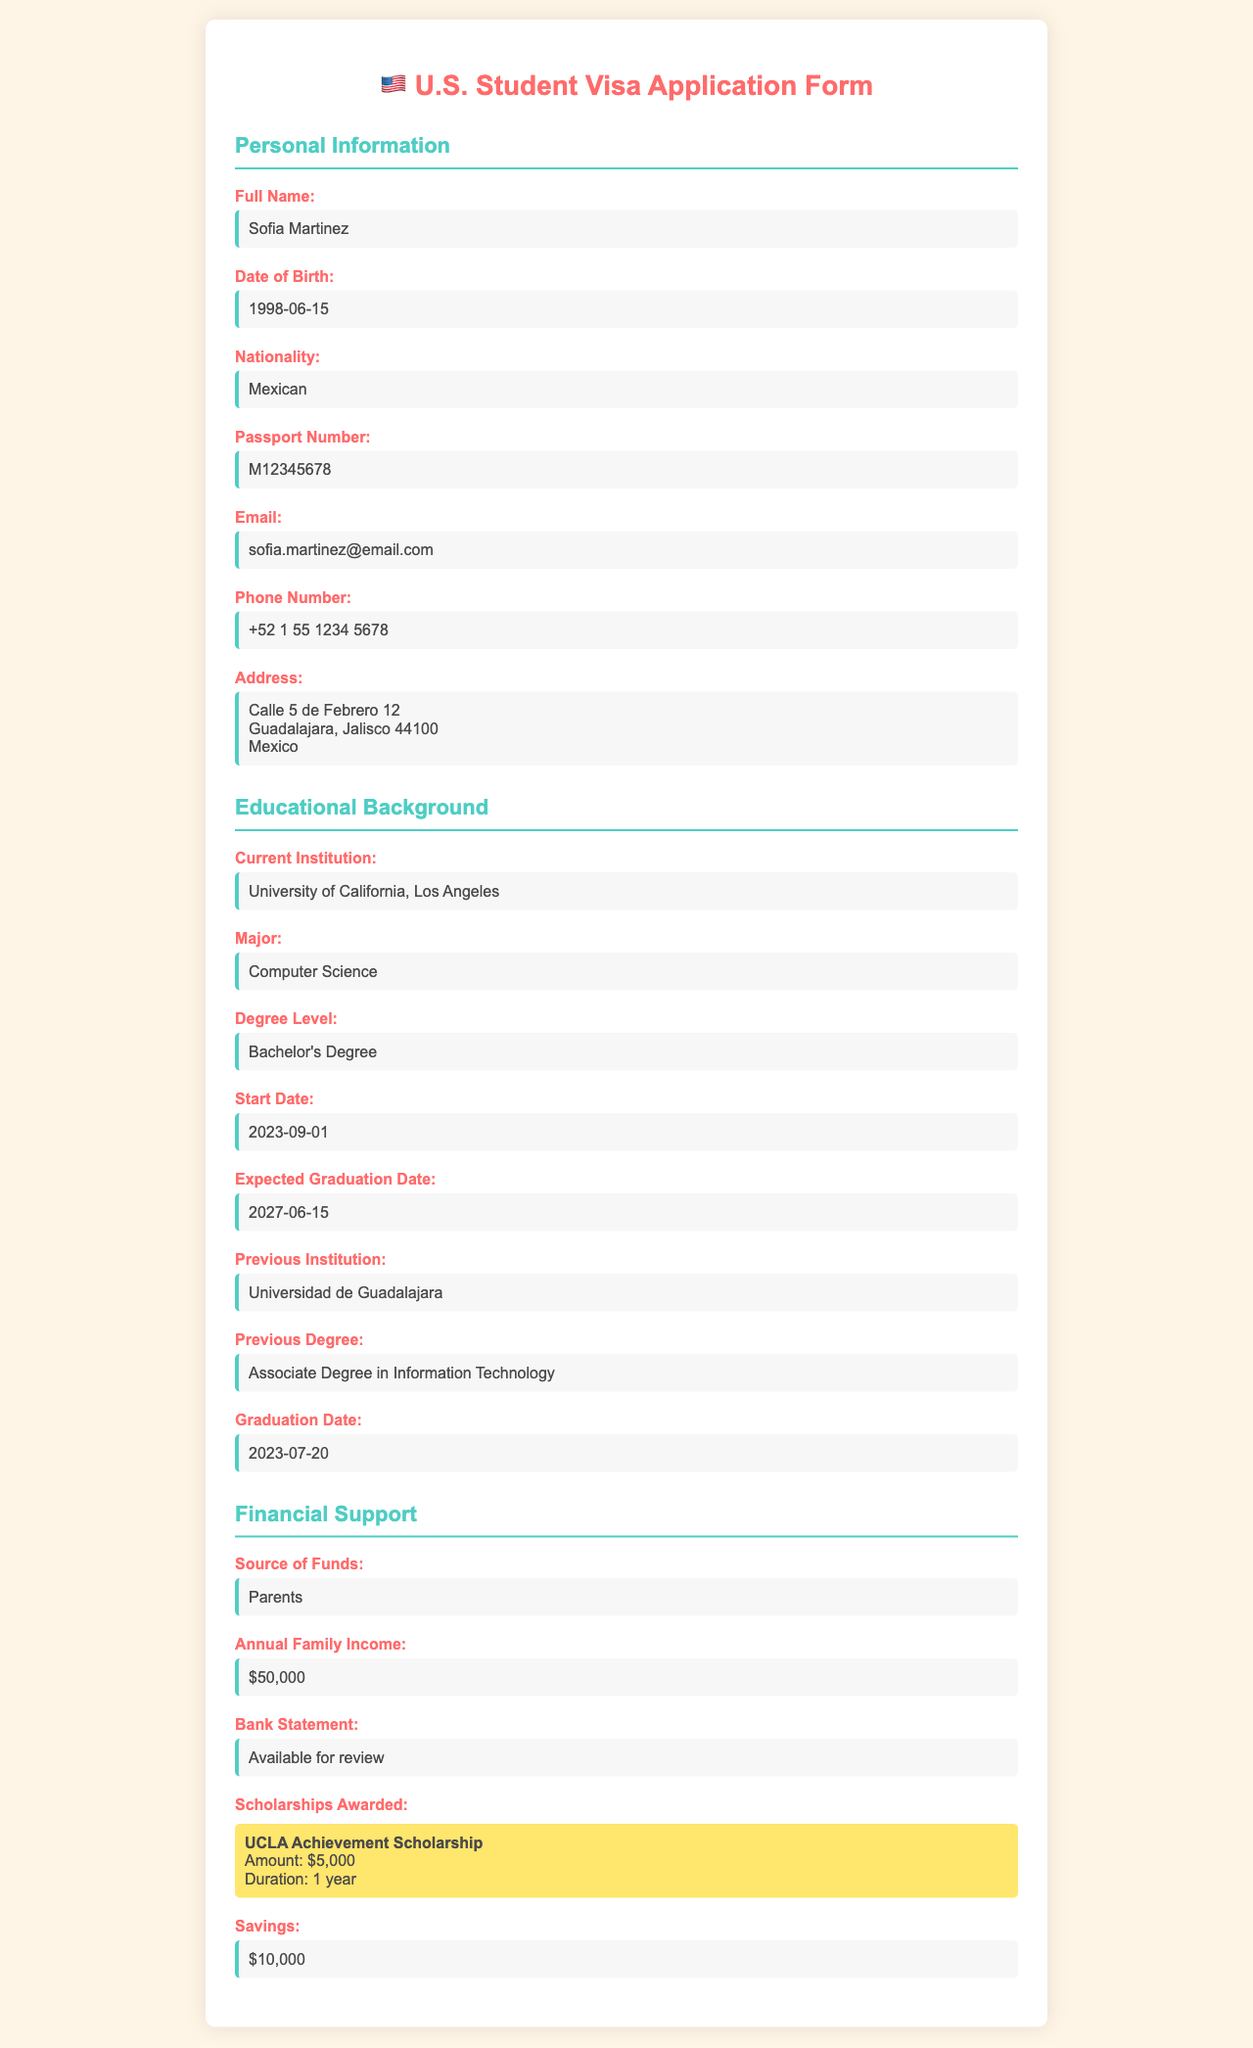What is the full name of the applicant? The applicant's full name is located in the Personal Information section.
Answer: Sofia Martinez What is the date of birth of the applicant? The date of birth can be found in the Personal Information section.
Answer: 1998-06-15 What is the major of the applicant's current institution? The applicant's major is indicated in the Educational Background section.
Answer: Computer Science What is the graduation date expected for the applicant? The expected graduation date is specified in the Educational Background section.
Answer: 2027-06-15 Who is the source of funds for the applicant's financial support? The source of funds is listed in the Financial Support section.
Answer: Parents What was the applicant's previous degree? The previous degree is mentioned in the Educational Background section.
Answer: Associate Degree in Information Technology How much is the annual family income? The annual family income is provided in the Financial Support section.
Answer: $50,000 What scholarship has been awarded to the applicant? The scholarship awarded is detailed in the Financial Support section, highlighting the specific scholarship name.
Answer: UCLA Achievement Scholarship What is the amount of the awarded scholarship? The scholarship amount is found in the Financial Support section under Scholarship details.
Answer: $5,000 